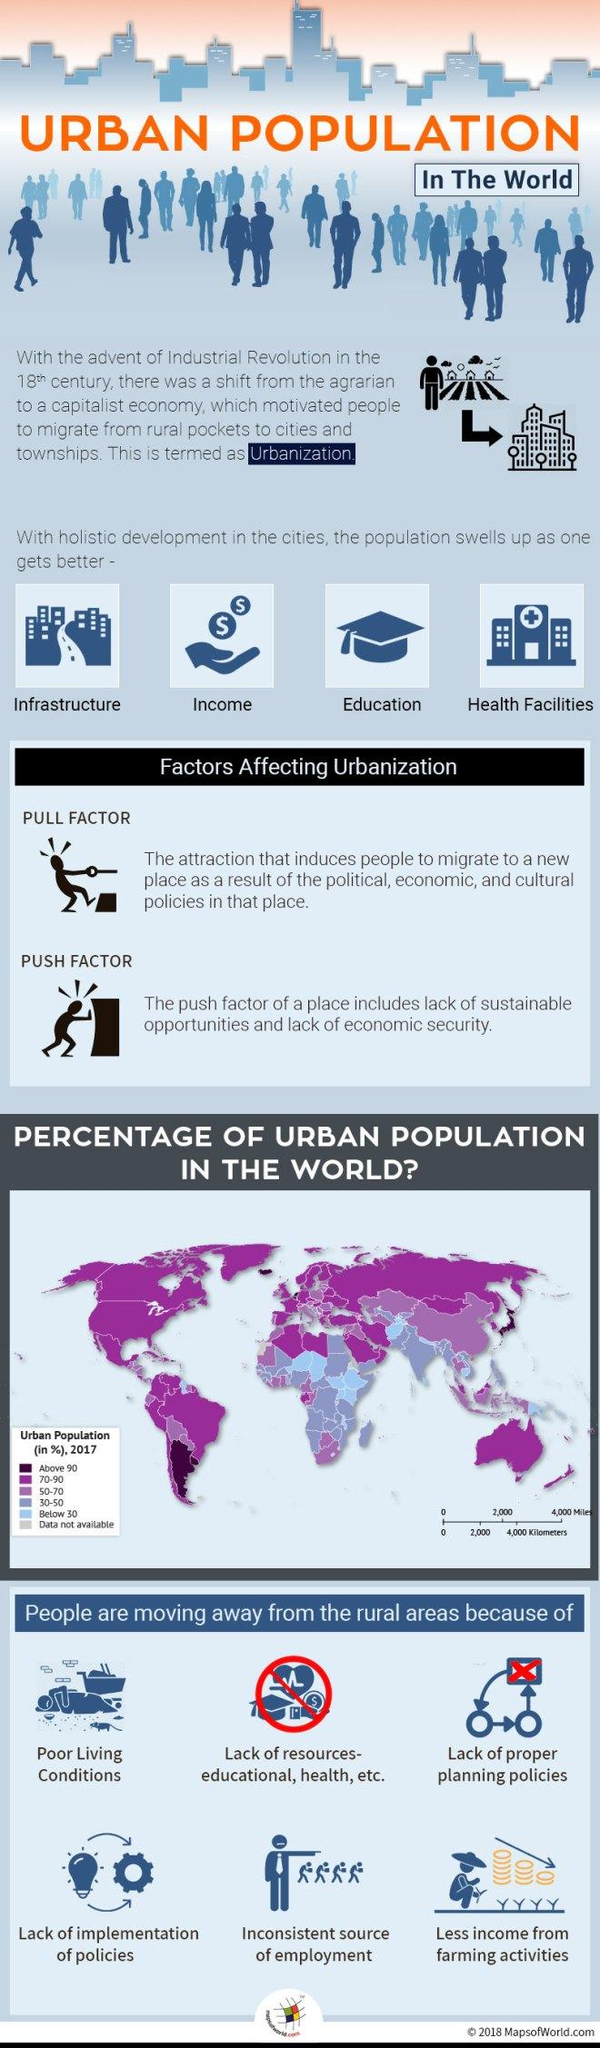Mention a couple of crucial points in this snapshot. In the northern-most part of the map, approximately 70-90% of the population resides in urban areas. The fourth attraction of cities, as listed in the infographic, is health facilities. People move to urban places for a variety of reasons, including inconsistent sources of employment. There are various factors that impact urbanization, including pull factors, such as better job opportunities and higher standard of living, and push factors, such as overpopulation, poverty, and lack of resources. The proportion of the population living in urban areas in the south-east island is estimated to be between 70% and 90%. 